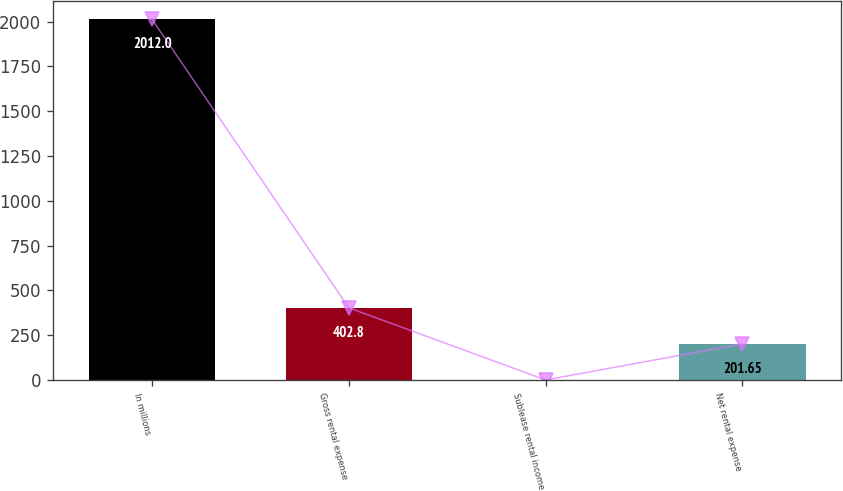Convert chart to OTSL. <chart><loc_0><loc_0><loc_500><loc_500><bar_chart><fcel>In millions<fcel>Gross rental expense<fcel>Sublease rental income<fcel>Net rental expense<nl><fcel>2012<fcel>402.8<fcel>0.5<fcel>201.65<nl></chart> 